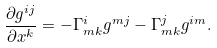<formula> <loc_0><loc_0><loc_500><loc_500>\frac { \partial g ^ { i j } } { \partial x ^ { k } } = - \Gamma _ { m k } ^ { i } g ^ { m j } - \Gamma _ { m k } ^ { j } g ^ { i m } .</formula> 